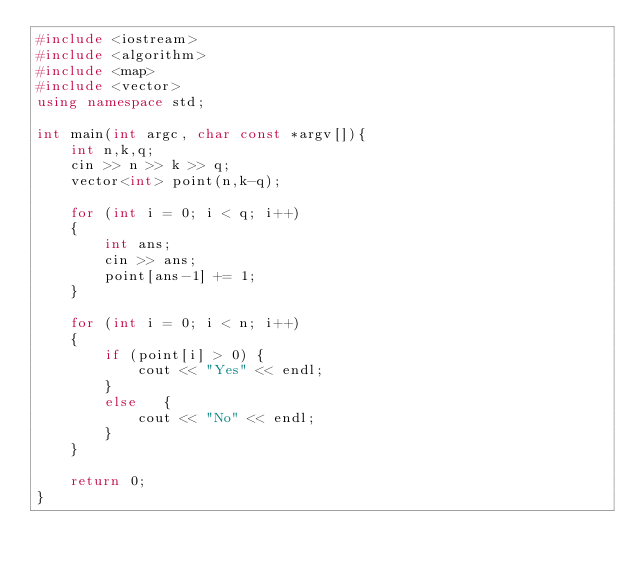Convert code to text. <code><loc_0><loc_0><loc_500><loc_500><_C++_>#include <iostream>
#include <algorithm>
#include <map>
#include <vector>
using namespace std;

int main(int argc, char const *argv[]){
    int n,k,q;
    cin >> n >> k >> q;
    vector<int> point(n,k-q);

    for (int i = 0; i < q; i++)
    {
        int ans;
        cin >> ans;
        point[ans-1] += 1;
    }
    
    for (int i = 0; i < n; i++)
    {
        if (point[i] > 0) {
            cout << "Yes" << endl;
        }
        else   {
            cout << "No" << endl; 
        }
    }
    
    return 0;
}
</code> 